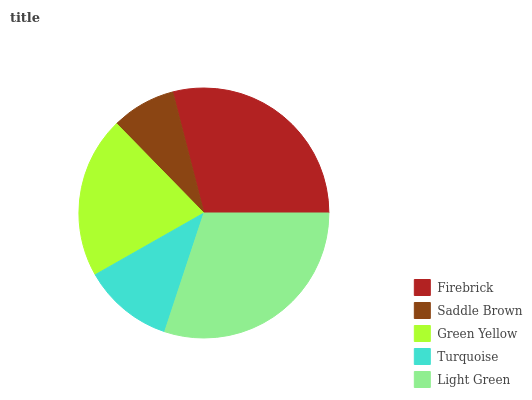Is Saddle Brown the minimum?
Answer yes or no. Yes. Is Light Green the maximum?
Answer yes or no. Yes. Is Green Yellow the minimum?
Answer yes or no. No. Is Green Yellow the maximum?
Answer yes or no. No. Is Green Yellow greater than Saddle Brown?
Answer yes or no. Yes. Is Saddle Brown less than Green Yellow?
Answer yes or no. Yes. Is Saddle Brown greater than Green Yellow?
Answer yes or no. No. Is Green Yellow less than Saddle Brown?
Answer yes or no. No. Is Green Yellow the high median?
Answer yes or no. Yes. Is Green Yellow the low median?
Answer yes or no. Yes. Is Turquoise the high median?
Answer yes or no. No. Is Saddle Brown the low median?
Answer yes or no. No. 